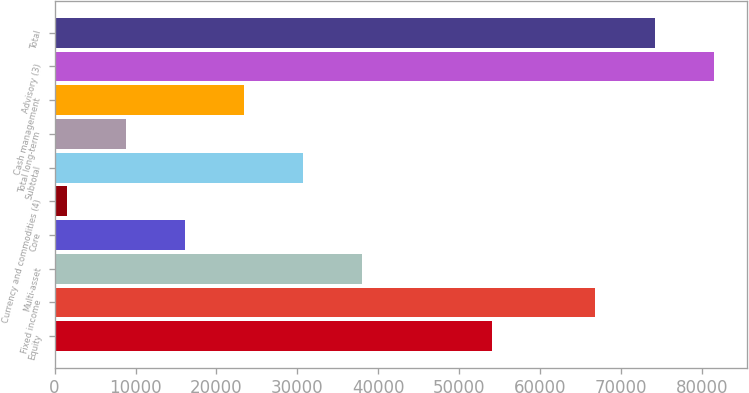Convert chart to OTSL. <chart><loc_0><loc_0><loc_500><loc_500><bar_chart><fcel>Equity<fcel>Fixed income<fcel>Multi-asset<fcel>Core<fcel>Currency and commodities (4)<fcel>Subtotal<fcel>Total long-term<fcel>Cash management<fcel>Advisory (3)<fcel>Total<nl><fcel>54016<fcel>66829<fcel>38043.5<fcel>16145.6<fcel>1547<fcel>30744.2<fcel>8846.3<fcel>23444.9<fcel>81427.6<fcel>74128.3<nl></chart> 